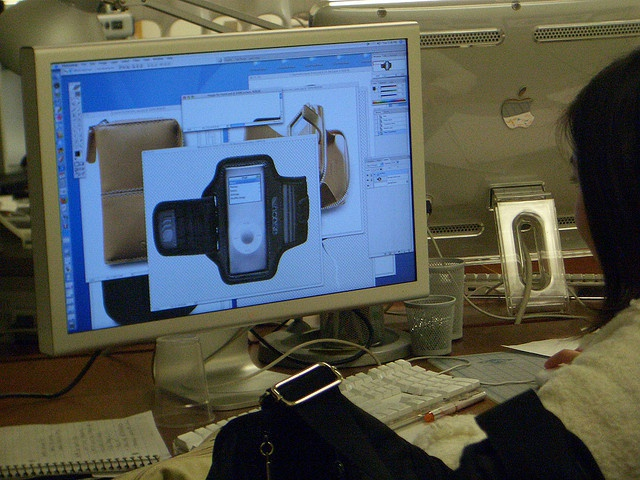Describe the objects in this image and their specific colors. I can see tv in maroon, darkgray, black, gray, and olive tones, people in maroon, black, and olive tones, handbag in maroon, black, olive, and gray tones, book in maroon, olive, black, and gray tones, and keyboard in maroon, olive, and gray tones in this image. 